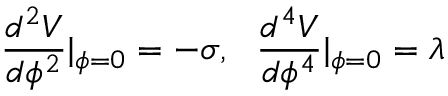Convert formula to latex. <formula><loc_0><loc_0><loc_500><loc_500>\frac { d ^ { 2 } V } { d \phi ^ { 2 } } | _ { \phi = 0 } = - \sigma , \frac { d ^ { 4 } V } { d \phi ^ { 4 } } | _ { \phi = 0 } = \lambda</formula> 